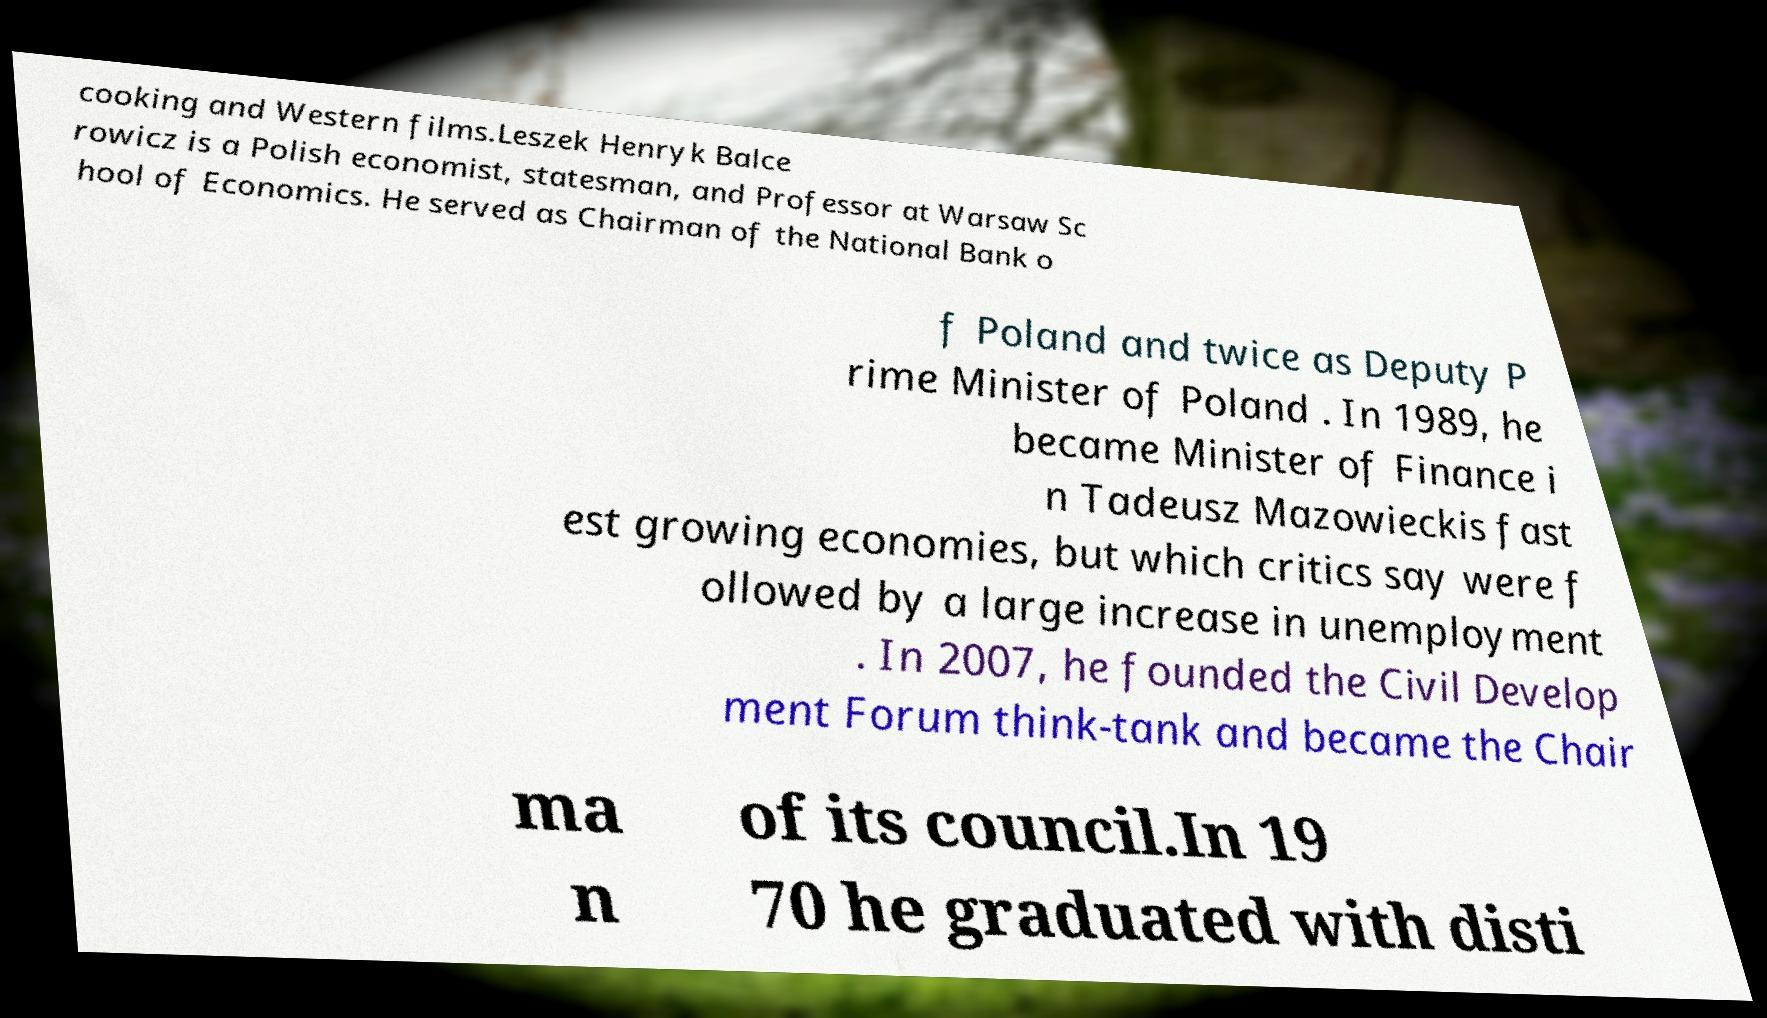Could you extract and type out the text from this image? cooking and Western films.Leszek Henryk Balce rowicz is a Polish economist, statesman, and Professor at Warsaw Sc hool of Economics. He served as Chairman of the National Bank o f Poland and twice as Deputy P rime Minister of Poland . In 1989, he became Minister of Finance i n Tadeusz Mazowieckis fast est growing economies, but which critics say were f ollowed by a large increase in unemployment . In 2007, he founded the Civil Develop ment Forum think-tank and became the Chair ma n of its council.In 19 70 he graduated with disti 